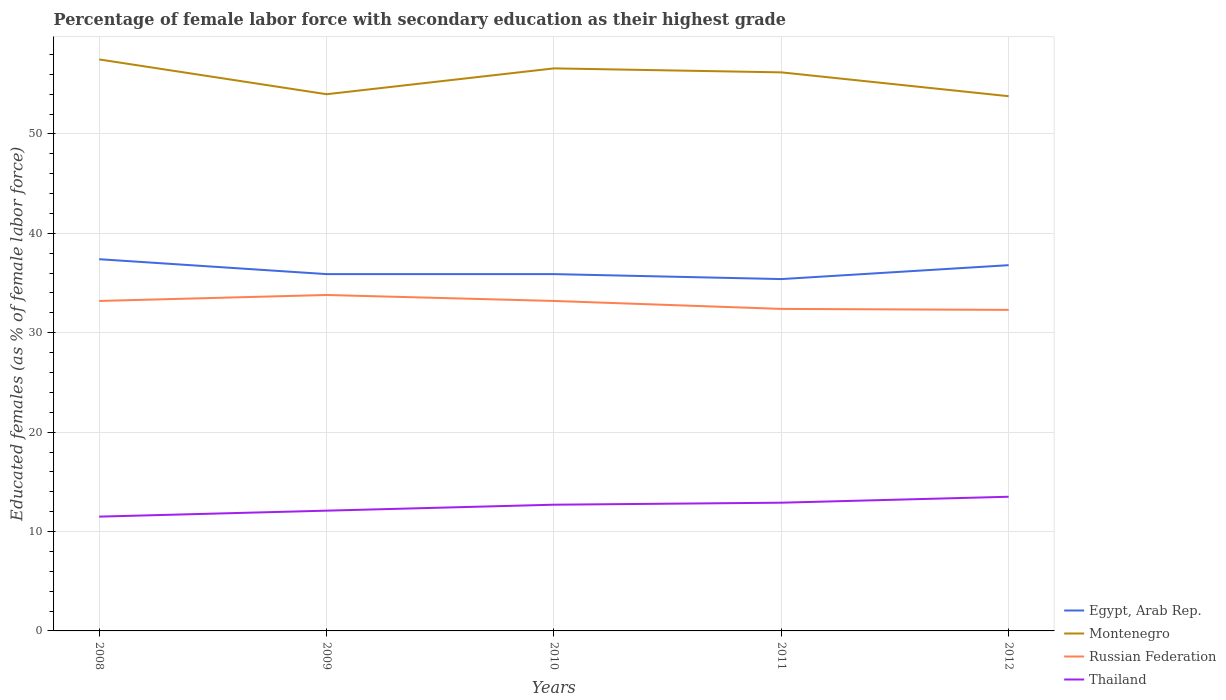Across all years, what is the maximum percentage of female labor force with secondary education in Russian Federation?
Ensure brevity in your answer.  32.3. What is the difference between the highest and the second highest percentage of female labor force with secondary education in Montenegro?
Provide a succinct answer. 3.7. What is the difference between the highest and the lowest percentage of female labor force with secondary education in Montenegro?
Your answer should be very brief. 3. Is the percentage of female labor force with secondary education in Russian Federation strictly greater than the percentage of female labor force with secondary education in Thailand over the years?
Offer a terse response. No. Are the values on the major ticks of Y-axis written in scientific E-notation?
Make the answer very short. No. What is the title of the graph?
Offer a terse response. Percentage of female labor force with secondary education as their highest grade. Does "Guatemala" appear as one of the legend labels in the graph?
Provide a short and direct response. No. What is the label or title of the Y-axis?
Provide a short and direct response. Educated females (as % of female labor force). What is the Educated females (as % of female labor force) of Egypt, Arab Rep. in 2008?
Offer a very short reply. 37.4. What is the Educated females (as % of female labor force) of Montenegro in 2008?
Offer a very short reply. 57.5. What is the Educated females (as % of female labor force) of Russian Federation in 2008?
Your response must be concise. 33.2. What is the Educated females (as % of female labor force) in Thailand in 2008?
Give a very brief answer. 11.5. What is the Educated females (as % of female labor force) in Egypt, Arab Rep. in 2009?
Make the answer very short. 35.9. What is the Educated females (as % of female labor force) in Montenegro in 2009?
Provide a succinct answer. 54. What is the Educated females (as % of female labor force) of Russian Federation in 2009?
Offer a very short reply. 33.8. What is the Educated females (as % of female labor force) of Thailand in 2009?
Give a very brief answer. 12.1. What is the Educated females (as % of female labor force) of Egypt, Arab Rep. in 2010?
Your response must be concise. 35.9. What is the Educated females (as % of female labor force) of Montenegro in 2010?
Give a very brief answer. 56.6. What is the Educated females (as % of female labor force) in Russian Federation in 2010?
Your answer should be compact. 33.2. What is the Educated females (as % of female labor force) of Thailand in 2010?
Keep it short and to the point. 12.7. What is the Educated females (as % of female labor force) in Egypt, Arab Rep. in 2011?
Offer a very short reply. 35.4. What is the Educated females (as % of female labor force) in Montenegro in 2011?
Your answer should be compact. 56.2. What is the Educated females (as % of female labor force) in Russian Federation in 2011?
Ensure brevity in your answer.  32.4. What is the Educated females (as % of female labor force) of Thailand in 2011?
Keep it short and to the point. 12.9. What is the Educated females (as % of female labor force) in Egypt, Arab Rep. in 2012?
Give a very brief answer. 36.8. What is the Educated females (as % of female labor force) in Montenegro in 2012?
Make the answer very short. 53.8. What is the Educated females (as % of female labor force) in Russian Federation in 2012?
Provide a short and direct response. 32.3. What is the Educated females (as % of female labor force) in Thailand in 2012?
Your answer should be very brief. 13.5. Across all years, what is the maximum Educated females (as % of female labor force) of Egypt, Arab Rep.?
Make the answer very short. 37.4. Across all years, what is the maximum Educated females (as % of female labor force) in Montenegro?
Your answer should be compact. 57.5. Across all years, what is the maximum Educated females (as % of female labor force) in Russian Federation?
Make the answer very short. 33.8. Across all years, what is the minimum Educated females (as % of female labor force) in Egypt, Arab Rep.?
Keep it short and to the point. 35.4. Across all years, what is the minimum Educated females (as % of female labor force) in Montenegro?
Offer a very short reply. 53.8. Across all years, what is the minimum Educated females (as % of female labor force) of Russian Federation?
Your answer should be compact. 32.3. Across all years, what is the minimum Educated females (as % of female labor force) of Thailand?
Your answer should be compact. 11.5. What is the total Educated females (as % of female labor force) in Egypt, Arab Rep. in the graph?
Give a very brief answer. 181.4. What is the total Educated females (as % of female labor force) of Montenegro in the graph?
Make the answer very short. 278.1. What is the total Educated females (as % of female labor force) of Russian Federation in the graph?
Offer a terse response. 164.9. What is the total Educated females (as % of female labor force) of Thailand in the graph?
Offer a terse response. 62.7. What is the difference between the Educated females (as % of female labor force) of Montenegro in 2008 and that in 2009?
Your answer should be compact. 3.5. What is the difference between the Educated females (as % of female labor force) in Russian Federation in 2008 and that in 2009?
Provide a short and direct response. -0.6. What is the difference between the Educated females (as % of female labor force) of Thailand in 2008 and that in 2009?
Your answer should be compact. -0.6. What is the difference between the Educated females (as % of female labor force) of Montenegro in 2008 and that in 2010?
Your answer should be very brief. 0.9. What is the difference between the Educated females (as % of female labor force) of Russian Federation in 2008 and that in 2010?
Make the answer very short. 0. What is the difference between the Educated females (as % of female labor force) in Egypt, Arab Rep. in 2008 and that in 2011?
Offer a very short reply. 2. What is the difference between the Educated females (as % of female labor force) of Montenegro in 2008 and that in 2011?
Your answer should be very brief. 1.3. What is the difference between the Educated females (as % of female labor force) in Russian Federation in 2008 and that in 2011?
Ensure brevity in your answer.  0.8. What is the difference between the Educated females (as % of female labor force) of Egypt, Arab Rep. in 2008 and that in 2012?
Keep it short and to the point. 0.6. What is the difference between the Educated females (as % of female labor force) in Montenegro in 2008 and that in 2012?
Provide a short and direct response. 3.7. What is the difference between the Educated females (as % of female labor force) of Russian Federation in 2008 and that in 2012?
Your answer should be compact. 0.9. What is the difference between the Educated females (as % of female labor force) of Thailand in 2008 and that in 2012?
Offer a very short reply. -2. What is the difference between the Educated females (as % of female labor force) of Montenegro in 2009 and that in 2010?
Provide a short and direct response. -2.6. What is the difference between the Educated females (as % of female labor force) in Russian Federation in 2009 and that in 2010?
Keep it short and to the point. 0.6. What is the difference between the Educated females (as % of female labor force) in Thailand in 2009 and that in 2010?
Provide a succinct answer. -0.6. What is the difference between the Educated females (as % of female labor force) of Egypt, Arab Rep. in 2009 and that in 2011?
Keep it short and to the point. 0.5. What is the difference between the Educated females (as % of female labor force) of Montenegro in 2009 and that in 2011?
Your answer should be very brief. -2.2. What is the difference between the Educated females (as % of female labor force) in Russian Federation in 2009 and that in 2011?
Provide a succinct answer. 1.4. What is the difference between the Educated females (as % of female labor force) in Thailand in 2009 and that in 2011?
Offer a very short reply. -0.8. What is the difference between the Educated females (as % of female labor force) of Thailand in 2009 and that in 2012?
Ensure brevity in your answer.  -1.4. What is the difference between the Educated females (as % of female labor force) of Montenegro in 2010 and that in 2011?
Your answer should be very brief. 0.4. What is the difference between the Educated females (as % of female labor force) in Thailand in 2010 and that in 2011?
Make the answer very short. -0.2. What is the difference between the Educated females (as % of female labor force) in Egypt, Arab Rep. in 2010 and that in 2012?
Offer a terse response. -0.9. What is the difference between the Educated females (as % of female labor force) of Russian Federation in 2010 and that in 2012?
Your answer should be very brief. 0.9. What is the difference between the Educated females (as % of female labor force) of Thailand in 2010 and that in 2012?
Provide a short and direct response. -0.8. What is the difference between the Educated females (as % of female labor force) of Egypt, Arab Rep. in 2011 and that in 2012?
Give a very brief answer. -1.4. What is the difference between the Educated females (as % of female labor force) in Thailand in 2011 and that in 2012?
Offer a very short reply. -0.6. What is the difference between the Educated females (as % of female labor force) of Egypt, Arab Rep. in 2008 and the Educated females (as % of female labor force) of Montenegro in 2009?
Make the answer very short. -16.6. What is the difference between the Educated females (as % of female labor force) of Egypt, Arab Rep. in 2008 and the Educated females (as % of female labor force) of Russian Federation in 2009?
Make the answer very short. 3.6. What is the difference between the Educated females (as % of female labor force) of Egypt, Arab Rep. in 2008 and the Educated females (as % of female labor force) of Thailand in 2009?
Offer a very short reply. 25.3. What is the difference between the Educated females (as % of female labor force) in Montenegro in 2008 and the Educated females (as % of female labor force) in Russian Federation in 2009?
Give a very brief answer. 23.7. What is the difference between the Educated females (as % of female labor force) of Montenegro in 2008 and the Educated females (as % of female labor force) of Thailand in 2009?
Make the answer very short. 45.4. What is the difference between the Educated females (as % of female labor force) in Russian Federation in 2008 and the Educated females (as % of female labor force) in Thailand in 2009?
Provide a short and direct response. 21.1. What is the difference between the Educated females (as % of female labor force) in Egypt, Arab Rep. in 2008 and the Educated females (as % of female labor force) in Montenegro in 2010?
Your answer should be compact. -19.2. What is the difference between the Educated females (as % of female labor force) in Egypt, Arab Rep. in 2008 and the Educated females (as % of female labor force) in Russian Federation in 2010?
Provide a short and direct response. 4.2. What is the difference between the Educated females (as % of female labor force) in Egypt, Arab Rep. in 2008 and the Educated females (as % of female labor force) in Thailand in 2010?
Keep it short and to the point. 24.7. What is the difference between the Educated females (as % of female labor force) in Montenegro in 2008 and the Educated females (as % of female labor force) in Russian Federation in 2010?
Offer a terse response. 24.3. What is the difference between the Educated females (as % of female labor force) of Montenegro in 2008 and the Educated females (as % of female labor force) of Thailand in 2010?
Give a very brief answer. 44.8. What is the difference between the Educated females (as % of female labor force) in Egypt, Arab Rep. in 2008 and the Educated females (as % of female labor force) in Montenegro in 2011?
Give a very brief answer. -18.8. What is the difference between the Educated females (as % of female labor force) of Montenegro in 2008 and the Educated females (as % of female labor force) of Russian Federation in 2011?
Your response must be concise. 25.1. What is the difference between the Educated females (as % of female labor force) in Montenegro in 2008 and the Educated females (as % of female labor force) in Thailand in 2011?
Ensure brevity in your answer.  44.6. What is the difference between the Educated females (as % of female labor force) in Russian Federation in 2008 and the Educated females (as % of female labor force) in Thailand in 2011?
Ensure brevity in your answer.  20.3. What is the difference between the Educated females (as % of female labor force) of Egypt, Arab Rep. in 2008 and the Educated females (as % of female labor force) of Montenegro in 2012?
Keep it short and to the point. -16.4. What is the difference between the Educated females (as % of female labor force) of Egypt, Arab Rep. in 2008 and the Educated females (as % of female labor force) of Russian Federation in 2012?
Ensure brevity in your answer.  5.1. What is the difference between the Educated females (as % of female labor force) of Egypt, Arab Rep. in 2008 and the Educated females (as % of female labor force) of Thailand in 2012?
Your answer should be compact. 23.9. What is the difference between the Educated females (as % of female labor force) of Montenegro in 2008 and the Educated females (as % of female labor force) of Russian Federation in 2012?
Make the answer very short. 25.2. What is the difference between the Educated females (as % of female labor force) of Egypt, Arab Rep. in 2009 and the Educated females (as % of female labor force) of Montenegro in 2010?
Your answer should be compact. -20.7. What is the difference between the Educated females (as % of female labor force) in Egypt, Arab Rep. in 2009 and the Educated females (as % of female labor force) in Russian Federation in 2010?
Provide a short and direct response. 2.7. What is the difference between the Educated females (as % of female labor force) of Egypt, Arab Rep. in 2009 and the Educated females (as % of female labor force) of Thailand in 2010?
Your answer should be very brief. 23.2. What is the difference between the Educated females (as % of female labor force) in Montenegro in 2009 and the Educated females (as % of female labor force) in Russian Federation in 2010?
Your response must be concise. 20.8. What is the difference between the Educated females (as % of female labor force) of Montenegro in 2009 and the Educated females (as % of female labor force) of Thailand in 2010?
Offer a terse response. 41.3. What is the difference between the Educated females (as % of female labor force) of Russian Federation in 2009 and the Educated females (as % of female labor force) of Thailand in 2010?
Give a very brief answer. 21.1. What is the difference between the Educated females (as % of female labor force) in Egypt, Arab Rep. in 2009 and the Educated females (as % of female labor force) in Montenegro in 2011?
Your answer should be compact. -20.3. What is the difference between the Educated females (as % of female labor force) of Montenegro in 2009 and the Educated females (as % of female labor force) of Russian Federation in 2011?
Make the answer very short. 21.6. What is the difference between the Educated females (as % of female labor force) of Montenegro in 2009 and the Educated females (as % of female labor force) of Thailand in 2011?
Your answer should be compact. 41.1. What is the difference between the Educated females (as % of female labor force) of Russian Federation in 2009 and the Educated females (as % of female labor force) of Thailand in 2011?
Your response must be concise. 20.9. What is the difference between the Educated females (as % of female labor force) of Egypt, Arab Rep. in 2009 and the Educated females (as % of female labor force) of Montenegro in 2012?
Keep it short and to the point. -17.9. What is the difference between the Educated females (as % of female labor force) in Egypt, Arab Rep. in 2009 and the Educated females (as % of female labor force) in Thailand in 2012?
Keep it short and to the point. 22.4. What is the difference between the Educated females (as % of female labor force) in Montenegro in 2009 and the Educated females (as % of female labor force) in Russian Federation in 2012?
Keep it short and to the point. 21.7. What is the difference between the Educated females (as % of female labor force) of Montenegro in 2009 and the Educated females (as % of female labor force) of Thailand in 2012?
Offer a terse response. 40.5. What is the difference between the Educated females (as % of female labor force) in Russian Federation in 2009 and the Educated females (as % of female labor force) in Thailand in 2012?
Ensure brevity in your answer.  20.3. What is the difference between the Educated females (as % of female labor force) in Egypt, Arab Rep. in 2010 and the Educated females (as % of female labor force) in Montenegro in 2011?
Your answer should be compact. -20.3. What is the difference between the Educated females (as % of female labor force) in Egypt, Arab Rep. in 2010 and the Educated females (as % of female labor force) in Russian Federation in 2011?
Your response must be concise. 3.5. What is the difference between the Educated females (as % of female labor force) in Egypt, Arab Rep. in 2010 and the Educated females (as % of female labor force) in Thailand in 2011?
Give a very brief answer. 23. What is the difference between the Educated females (as % of female labor force) of Montenegro in 2010 and the Educated females (as % of female labor force) of Russian Federation in 2011?
Your answer should be compact. 24.2. What is the difference between the Educated females (as % of female labor force) in Montenegro in 2010 and the Educated females (as % of female labor force) in Thailand in 2011?
Give a very brief answer. 43.7. What is the difference between the Educated females (as % of female labor force) of Russian Federation in 2010 and the Educated females (as % of female labor force) of Thailand in 2011?
Your response must be concise. 20.3. What is the difference between the Educated females (as % of female labor force) of Egypt, Arab Rep. in 2010 and the Educated females (as % of female labor force) of Montenegro in 2012?
Offer a terse response. -17.9. What is the difference between the Educated females (as % of female labor force) of Egypt, Arab Rep. in 2010 and the Educated females (as % of female labor force) of Thailand in 2012?
Offer a terse response. 22.4. What is the difference between the Educated females (as % of female labor force) of Montenegro in 2010 and the Educated females (as % of female labor force) of Russian Federation in 2012?
Give a very brief answer. 24.3. What is the difference between the Educated females (as % of female labor force) in Montenegro in 2010 and the Educated females (as % of female labor force) in Thailand in 2012?
Your response must be concise. 43.1. What is the difference between the Educated females (as % of female labor force) of Egypt, Arab Rep. in 2011 and the Educated females (as % of female labor force) of Montenegro in 2012?
Make the answer very short. -18.4. What is the difference between the Educated females (as % of female labor force) of Egypt, Arab Rep. in 2011 and the Educated females (as % of female labor force) of Russian Federation in 2012?
Keep it short and to the point. 3.1. What is the difference between the Educated females (as % of female labor force) of Egypt, Arab Rep. in 2011 and the Educated females (as % of female labor force) of Thailand in 2012?
Your response must be concise. 21.9. What is the difference between the Educated females (as % of female labor force) of Montenegro in 2011 and the Educated females (as % of female labor force) of Russian Federation in 2012?
Keep it short and to the point. 23.9. What is the difference between the Educated females (as % of female labor force) of Montenegro in 2011 and the Educated females (as % of female labor force) of Thailand in 2012?
Provide a short and direct response. 42.7. What is the difference between the Educated females (as % of female labor force) of Russian Federation in 2011 and the Educated females (as % of female labor force) of Thailand in 2012?
Your answer should be very brief. 18.9. What is the average Educated females (as % of female labor force) in Egypt, Arab Rep. per year?
Offer a terse response. 36.28. What is the average Educated females (as % of female labor force) of Montenegro per year?
Keep it short and to the point. 55.62. What is the average Educated females (as % of female labor force) in Russian Federation per year?
Make the answer very short. 32.98. What is the average Educated females (as % of female labor force) in Thailand per year?
Provide a succinct answer. 12.54. In the year 2008, what is the difference between the Educated females (as % of female labor force) in Egypt, Arab Rep. and Educated females (as % of female labor force) in Montenegro?
Provide a succinct answer. -20.1. In the year 2008, what is the difference between the Educated females (as % of female labor force) in Egypt, Arab Rep. and Educated females (as % of female labor force) in Russian Federation?
Keep it short and to the point. 4.2. In the year 2008, what is the difference between the Educated females (as % of female labor force) in Egypt, Arab Rep. and Educated females (as % of female labor force) in Thailand?
Provide a short and direct response. 25.9. In the year 2008, what is the difference between the Educated females (as % of female labor force) of Montenegro and Educated females (as % of female labor force) of Russian Federation?
Provide a short and direct response. 24.3. In the year 2008, what is the difference between the Educated females (as % of female labor force) in Russian Federation and Educated females (as % of female labor force) in Thailand?
Your answer should be compact. 21.7. In the year 2009, what is the difference between the Educated females (as % of female labor force) in Egypt, Arab Rep. and Educated females (as % of female labor force) in Montenegro?
Offer a very short reply. -18.1. In the year 2009, what is the difference between the Educated females (as % of female labor force) in Egypt, Arab Rep. and Educated females (as % of female labor force) in Russian Federation?
Keep it short and to the point. 2.1. In the year 2009, what is the difference between the Educated females (as % of female labor force) of Egypt, Arab Rep. and Educated females (as % of female labor force) of Thailand?
Offer a terse response. 23.8. In the year 2009, what is the difference between the Educated females (as % of female labor force) of Montenegro and Educated females (as % of female labor force) of Russian Federation?
Your answer should be compact. 20.2. In the year 2009, what is the difference between the Educated females (as % of female labor force) in Montenegro and Educated females (as % of female labor force) in Thailand?
Give a very brief answer. 41.9. In the year 2009, what is the difference between the Educated females (as % of female labor force) in Russian Federation and Educated females (as % of female labor force) in Thailand?
Your answer should be very brief. 21.7. In the year 2010, what is the difference between the Educated females (as % of female labor force) of Egypt, Arab Rep. and Educated females (as % of female labor force) of Montenegro?
Give a very brief answer. -20.7. In the year 2010, what is the difference between the Educated females (as % of female labor force) of Egypt, Arab Rep. and Educated females (as % of female labor force) of Thailand?
Offer a terse response. 23.2. In the year 2010, what is the difference between the Educated females (as % of female labor force) of Montenegro and Educated females (as % of female labor force) of Russian Federation?
Ensure brevity in your answer.  23.4. In the year 2010, what is the difference between the Educated females (as % of female labor force) in Montenegro and Educated females (as % of female labor force) in Thailand?
Provide a succinct answer. 43.9. In the year 2011, what is the difference between the Educated females (as % of female labor force) in Egypt, Arab Rep. and Educated females (as % of female labor force) in Montenegro?
Keep it short and to the point. -20.8. In the year 2011, what is the difference between the Educated females (as % of female labor force) of Montenegro and Educated females (as % of female labor force) of Russian Federation?
Offer a terse response. 23.8. In the year 2011, what is the difference between the Educated females (as % of female labor force) in Montenegro and Educated females (as % of female labor force) in Thailand?
Provide a succinct answer. 43.3. In the year 2011, what is the difference between the Educated females (as % of female labor force) of Russian Federation and Educated females (as % of female labor force) of Thailand?
Provide a succinct answer. 19.5. In the year 2012, what is the difference between the Educated females (as % of female labor force) of Egypt, Arab Rep. and Educated females (as % of female labor force) of Montenegro?
Offer a terse response. -17. In the year 2012, what is the difference between the Educated females (as % of female labor force) of Egypt, Arab Rep. and Educated females (as % of female labor force) of Russian Federation?
Give a very brief answer. 4.5. In the year 2012, what is the difference between the Educated females (as % of female labor force) of Egypt, Arab Rep. and Educated females (as % of female labor force) of Thailand?
Your answer should be compact. 23.3. In the year 2012, what is the difference between the Educated females (as % of female labor force) of Montenegro and Educated females (as % of female labor force) of Russian Federation?
Provide a succinct answer. 21.5. In the year 2012, what is the difference between the Educated females (as % of female labor force) of Montenegro and Educated females (as % of female labor force) of Thailand?
Offer a very short reply. 40.3. In the year 2012, what is the difference between the Educated females (as % of female labor force) in Russian Federation and Educated females (as % of female labor force) in Thailand?
Give a very brief answer. 18.8. What is the ratio of the Educated females (as % of female labor force) of Egypt, Arab Rep. in 2008 to that in 2009?
Give a very brief answer. 1.04. What is the ratio of the Educated females (as % of female labor force) in Montenegro in 2008 to that in 2009?
Ensure brevity in your answer.  1.06. What is the ratio of the Educated females (as % of female labor force) of Russian Federation in 2008 to that in 2009?
Your answer should be very brief. 0.98. What is the ratio of the Educated females (as % of female labor force) in Thailand in 2008 to that in 2009?
Your answer should be compact. 0.95. What is the ratio of the Educated females (as % of female labor force) of Egypt, Arab Rep. in 2008 to that in 2010?
Your response must be concise. 1.04. What is the ratio of the Educated females (as % of female labor force) of Montenegro in 2008 to that in 2010?
Your answer should be very brief. 1.02. What is the ratio of the Educated females (as % of female labor force) in Russian Federation in 2008 to that in 2010?
Keep it short and to the point. 1. What is the ratio of the Educated females (as % of female labor force) in Thailand in 2008 to that in 2010?
Keep it short and to the point. 0.91. What is the ratio of the Educated females (as % of female labor force) of Egypt, Arab Rep. in 2008 to that in 2011?
Keep it short and to the point. 1.06. What is the ratio of the Educated females (as % of female labor force) of Montenegro in 2008 to that in 2011?
Your answer should be very brief. 1.02. What is the ratio of the Educated females (as % of female labor force) of Russian Federation in 2008 to that in 2011?
Provide a short and direct response. 1.02. What is the ratio of the Educated females (as % of female labor force) of Thailand in 2008 to that in 2011?
Your answer should be compact. 0.89. What is the ratio of the Educated females (as % of female labor force) in Egypt, Arab Rep. in 2008 to that in 2012?
Provide a short and direct response. 1.02. What is the ratio of the Educated females (as % of female labor force) in Montenegro in 2008 to that in 2012?
Your response must be concise. 1.07. What is the ratio of the Educated females (as % of female labor force) of Russian Federation in 2008 to that in 2012?
Make the answer very short. 1.03. What is the ratio of the Educated females (as % of female labor force) in Thailand in 2008 to that in 2012?
Your response must be concise. 0.85. What is the ratio of the Educated females (as % of female labor force) in Egypt, Arab Rep. in 2009 to that in 2010?
Make the answer very short. 1. What is the ratio of the Educated females (as % of female labor force) of Montenegro in 2009 to that in 2010?
Ensure brevity in your answer.  0.95. What is the ratio of the Educated females (as % of female labor force) of Russian Federation in 2009 to that in 2010?
Make the answer very short. 1.02. What is the ratio of the Educated females (as % of female labor force) in Thailand in 2009 to that in 2010?
Offer a very short reply. 0.95. What is the ratio of the Educated females (as % of female labor force) in Egypt, Arab Rep. in 2009 to that in 2011?
Your response must be concise. 1.01. What is the ratio of the Educated females (as % of female labor force) in Montenegro in 2009 to that in 2011?
Ensure brevity in your answer.  0.96. What is the ratio of the Educated females (as % of female labor force) of Russian Federation in 2009 to that in 2011?
Make the answer very short. 1.04. What is the ratio of the Educated females (as % of female labor force) of Thailand in 2009 to that in 2011?
Your answer should be compact. 0.94. What is the ratio of the Educated females (as % of female labor force) of Egypt, Arab Rep. in 2009 to that in 2012?
Your response must be concise. 0.98. What is the ratio of the Educated females (as % of female labor force) in Russian Federation in 2009 to that in 2012?
Provide a short and direct response. 1.05. What is the ratio of the Educated females (as % of female labor force) in Thailand in 2009 to that in 2012?
Offer a very short reply. 0.9. What is the ratio of the Educated females (as % of female labor force) in Egypt, Arab Rep. in 2010 to that in 2011?
Offer a very short reply. 1.01. What is the ratio of the Educated females (as % of female labor force) of Montenegro in 2010 to that in 2011?
Provide a short and direct response. 1.01. What is the ratio of the Educated females (as % of female labor force) in Russian Federation in 2010 to that in 2011?
Provide a succinct answer. 1.02. What is the ratio of the Educated females (as % of female labor force) in Thailand in 2010 to that in 2011?
Give a very brief answer. 0.98. What is the ratio of the Educated females (as % of female labor force) of Egypt, Arab Rep. in 2010 to that in 2012?
Provide a succinct answer. 0.98. What is the ratio of the Educated females (as % of female labor force) in Montenegro in 2010 to that in 2012?
Make the answer very short. 1.05. What is the ratio of the Educated females (as % of female labor force) in Russian Federation in 2010 to that in 2012?
Keep it short and to the point. 1.03. What is the ratio of the Educated females (as % of female labor force) in Thailand in 2010 to that in 2012?
Your answer should be very brief. 0.94. What is the ratio of the Educated females (as % of female labor force) of Montenegro in 2011 to that in 2012?
Give a very brief answer. 1.04. What is the ratio of the Educated females (as % of female labor force) in Russian Federation in 2011 to that in 2012?
Your answer should be very brief. 1. What is the ratio of the Educated females (as % of female labor force) of Thailand in 2011 to that in 2012?
Ensure brevity in your answer.  0.96. What is the difference between the highest and the second highest Educated females (as % of female labor force) in Russian Federation?
Ensure brevity in your answer.  0.6. What is the difference between the highest and the lowest Educated females (as % of female labor force) in Montenegro?
Ensure brevity in your answer.  3.7. What is the difference between the highest and the lowest Educated females (as % of female labor force) in Thailand?
Your answer should be very brief. 2. 